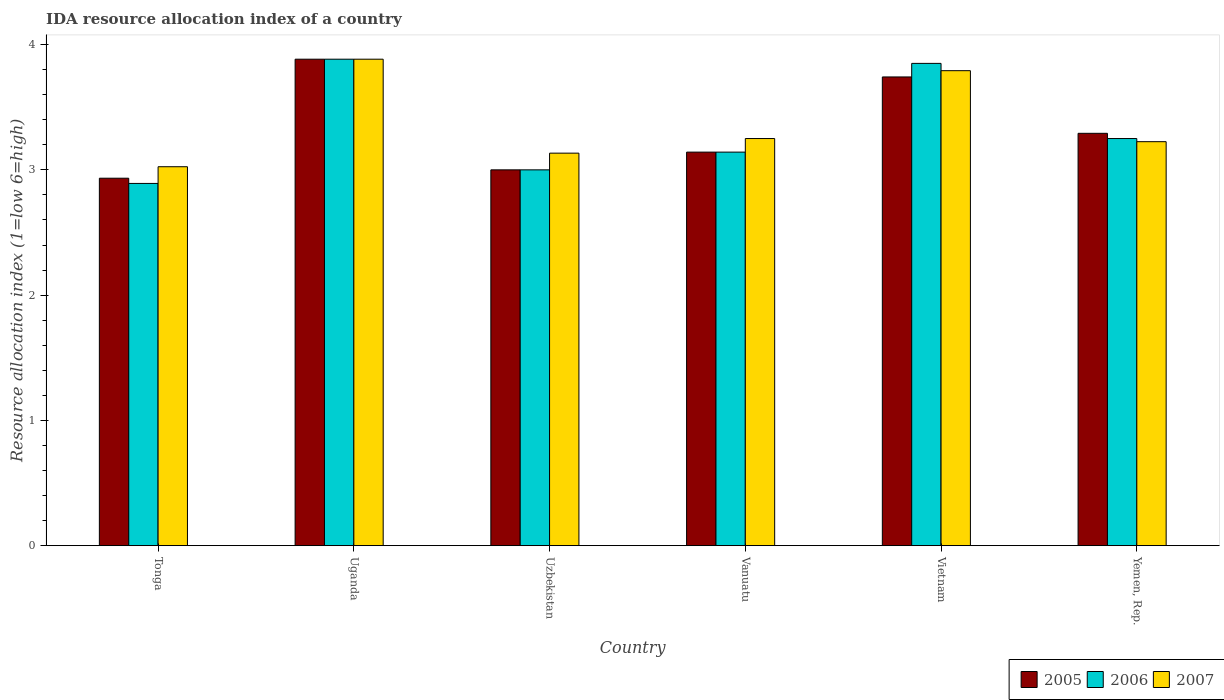How many groups of bars are there?
Offer a terse response. 6. Are the number of bars per tick equal to the number of legend labels?
Your response must be concise. Yes. How many bars are there on the 6th tick from the left?
Offer a very short reply. 3. How many bars are there on the 6th tick from the right?
Give a very brief answer. 3. What is the label of the 3rd group of bars from the left?
Ensure brevity in your answer.  Uzbekistan. What is the IDA resource allocation index in 2006 in Uzbekistan?
Make the answer very short. 3. Across all countries, what is the maximum IDA resource allocation index in 2005?
Your answer should be very brief. 3.88. Across all countries, what is the minimum IDA resource allocation index in 2006?
Offer a very short reply. 2.89. In which country was the IDA resource allocation index in 2007 maximum?
Offer a terse response. Uganda. In which country was the IDA resource allocation index in 2005 minimum?
Your answer should be compact. Tonga. What is the total IDA resource allocation index in 2005 in the graph?
Your answer should be very brief. 19.99. What is the difference between the IDA resource allocation index in 2006 in Tonga and that in Uzbekistan?
Offer a very short reply. -0.11. What is the difference between the IDA resource allocation index in 2005 in Vietnam and the IDA resource allocation index in 2007 in Tonga?
Keep it short and to the point. 0.72. What is the average IDA resource allocation index in 2005 per country?
Your answer should be very brief. 3.33. What is the difference between the IDA resource allocation index of/in 2005 and IDA resource allocation index of/in 2006 in Vietnam?
Offer a very short reply. -0.11. What is the ratio of the IDA resource allocation index in 2006 in Tonga to that in Vietnam?
Your response must be concise. 0.75. Is the difference between the IDA resource allocation index in 2005 in Tonga and Vietnam greater than the difference between the IDA resource allocation index in 2006 in Tonga and Vietnam?
Your answer should be compact. Yes. What is the difference between the highest and the second highest IDA resource allocation index in 2006?
Make the answer very short. 0.6. What is the difference between the highest and the lowest IDA resource allocation index in 2007?
Your answer should be compact. 0.86. Is the sum of the IDA resource allocation index in 2005 in Uganda and Uzbekistan greater than the maximum IDA resource allocation index in 2007 across all countries?
Offer a very short reply. Yes. Is it the case that in every country, the sum of the IDA resource allocation index in 2007 and IDA resource allocation index in 2005 is greater than the IDA resource allocation index in 2006?
Give a very brief answer. Yes. How many bars are there?
Offer a terse response. 18. Are all the bars in the graph horizontal?
Provide a short and direct response. No. How many countries are there in the graph?
Keep it short and to the point. 6. Does the graph contain grids?
Give a very brief answer. No. Where does the legend appear in the graph?
Your answer should be very brief. Bottom right. How many legend labels are there?
Keep it short and to the point. 3. How are the legend labels stacked?
Ensure brevity in your answer.  Horizontal. What is the title of the graph?
Make the answer very short. IDA resource allocation index of a country. Does "1964" appear as one of the legend labels in the graph?
Offer a very short reply. No. What is the label or title of the Y-axis?
Your answer should be compact. Resource allocation index (1=low 6=high). What is the Resource allocation index (1=low 6=high) in 2005 in Tonga?
Keep it short and to the point. 2.93. What is the Resource allocation index (1=low 6=high) of 2006 in Tonga?
Your response must be concise. 2.89. What is the Resource allocation index (1=low 6=high) of 2007 in Tonga?
Provide a succinct answer. 3.02. What is the Resource allocation index (1=low 6=high) of 2005 in Uganda?
Your answer should be very brief. 3.88. What is the Resource allocation index (1=low 6=high) of 2006 in Uganda?
Make the answer very short. 3.88. What is the Resource allocation index (1=low 6=high) in 2007 in Uganda?
Give a very brief answer. 3.88. What is the Resource allocation index (1=low 6=high) of 2005 in Uzbekistan?
Your response must be concise. 3. What is the Resource allocation index (1=low 6=high) of 2007 in Uzbekistan?
Offer a terse response. 3.13. What is the Resource allocation index (1=low 6=high) in 2005 in Vanuatu?
Your answer should be compact. 3.14. What is the Resource allocation index (1=low 6=high) in 2006 in Vanuatu?
Make the answer very short. 3.14. What is the Resource allocation index (1=low 6=high) in 2005 in Vietnam?
Provide a short and direct response. 3.74. What is the Resource allocation index (1=low 6=high) in 2006 in Vietnam?
Your answer should be very brief. 3.85. What is the Resource allocation index (1=low 6=high) of 2007 in Vietnam?
Offer a terse response. 3.79. What is the Resource allocation index (1=low 6=high) in 2005 in Yemen, Rep.?
Your response must be concise. 3.29. What is the Resource allocation index (1=low 6=high) of 2007 in Yemen, Rep.?
Provide a succinct answer. 3.23. Across all countries, what is the maximum Resource allocation index (1=low 6=high) of 2005?
Give a very brief answer. 3.88. Across all countries, what is the maximum Resource allocation index (1=low 6=high) of 2006?
Offer a terse response. 3.88. Across all countries, what is the maximum Resource allocation index (1=low 6=high) of 2007?
Your response must be concise. 3.88. Across all countries, what is the minimum Resource allocation index (1=low 6=high) of 2005?
Your answer should be compact. 2.93. Across all countries, what is the minimum Resource allocation index (1=low 6=high) in 2006?
Provide a short and direct response. 2.89. Across all countries, what is the minimum Resource allocation index (1=low 6=high) in 2007?
Your answer should be very brief. 3.02. What is the total Resource allocation index (1=low 6=high) of 2005 in the graph?
Provide a succinct answer. 19.99. What is the total Resource allocation index (1=low 6=high) of 2006 in the graph?
Give a very brief answer. 20.02. What is the total Resource allocation index (1=low 6=high) of 2007 in the graph?
Your response must be concise. 20.31. What is the difference between the Resource allocation index (1=low 6=high) in 2005 in Tonga and that in Uganda?
Offer a very short reply. -0.95. What is the difference between the Resource allocation index (1=low 6=high) in 2006 in Tonga and that in Uganda?
Provide a succinct answer. -0.99. What is the difference between the Resource allocation index (1=low 6=high) of 2007 in Tonga and that in Uganda?
Provide a succinct answer. -0.86. What is the difference between the Resource allocation index (1=low 6=high) in 2005 in Tonga and that in Uzbekistan?
Ensure brevity in your answer.  -0.07. What is the difference between the Resource allocation index (1=low 6=high) in 2006 in Tonga and that in Uzbekistan?
Your answer should be compact. -0.11. What is the difference between the Resource allocation index (1=low 6=high) of 2007 in Tonga and that in Uzbekistan?
Offer a very short reply. -0.11. What is the difference between the Resource allocation index (1=low 6=high) of 2005 in Tonga and that in Vanuatu?
Offer a very short reply. -0.21. What is the difference between the Resource allocation index (1=low 6=high) of 2006 in Tonga and that in Vanuatu?
Keep it short and to the point. -0.25. What is the difference between the Resource allocation index (1=low 6=high) of 2007 in Tonga and that in Vanuatu?
Give a very brief answer. -0.23. What is the difference between the Resource allocation index (1=low 6=high) of 2005 in Tonga and that in Vietnam?
Give a very brief answer. -0.81. What is the difference between the Resource allocation index (1=low 6=high) in 2006 in Tonga and that in Vietnam?
Your answer should be compact. -0.96. What is the difference between the Resource allocation index (1=low 6=high) of 2007 in Tonga and that in Vietnam?
Keep it short and to the point. -0.77. What is the difference between the Resource allocation index (1=low 6=high) of 2005 in Tonga and that in Yemen, Rep.?
Your answer should be compact. -0.36. What is the difference between the Resource allocation index (1=low 6=high) of 2006 in Tonga and that in Yemen, Rep.?
Offer a very short reply. -0.36. What is the difference between the Resource allocation index (1=low 6=high) of 2005 in Uganda and that in Uzbekistan?
Give a very brief answer. 0.88. What is the difference between the Resource allocation index (1=low 6=high) of 2006 in Uganda and that in Uzbekistan?
Your response must be concise. 0.88. What is the difference between the Resource allocation index (1=low 6=high) of 2005 in Uganda and that in Vanuatu?
Your response must be concise. 0.74. What is the difference between the Resource allocation index (1=low 6=high) in 2006 in Uganda and that in Vanuatu?
Offer a very short reply. 0.74. What is the difference between the Resource allocation index (1=low 6=high) in 2007 in Uganda and that in Vanuatu?
Keep it short and to the point. 0.63. What is the difference between the Resource allocation index (1=low 6=high) of 2005 in Uganda and that in Vietnam?
Your response must be concise. 0.14. What is the difference between the Resource allocation index (1=low 6=high) of 2006 in Uganda and that in Vietnam?
Your answer should be compact. 0.03. What is the difference between the Resource allocation index (1=low 6=high) of 2007 in Uganda and that in Vietnam?
Your answer should be very brief. 0.09. What is the difference between the Resource allocation index (1=low 6=high) of 2005 in Uganda and that in Yemen, Rep.?
Offer a terse response. 0.59. What is the difference between the Resource allocation index (1=low 6=high) of 2006 in Uganda and that in Yemen, Rep.?
Keep it short and to the point. 0.63. What is the difference between the Resource allocation index (1=low 6=high) in 2007 in Uganda and that in Yemen, Rep.?
Your answer should be compact. 0.66. What is the difference between the Resource allocation index (1=low 6=high) in 2005 in Uzbekistan and that in Vanuatu?
Provide a short and direct response. -0.14. What is the difference between the Resource allocation index (1=low 6=high) of 2006 in Uzbekistan and that in Vanuatu?
Ensure brevity in your answer.  -0.14. What is the difference between the Resource allocation index (1=low 6=high) of 2007 in Uzbekistan and that in Vanuatu?
Your answer should be very brief. -0.12. What is the difference between the Resource allocation index (1=low 6=high) of 2005 in Uzbekistan and that in Vietnam?
Provide a succinct answer. -0.74. What is the difference between the Resource allocation index (1=low 6=high) in 2006 in Uzbekistan and that in Vietnam?
Provide a short and direct response. -0.85. What is the difference between the Resource allocation index (1=low 6=high) in 2007 in Uzbekistan and that in Vietnam?
Your answer should be very brief. -0.66. What is the difference between the Resource allocation index (1=low 6=high) of 2005 in Uzbekistan and that in Yemen, Rep.?
Offer a very short reply. -0.29. What is the difference between the Resource allocation index (1=low 6=high) of 2006 in Uzbekistan and that in Yemen, Rep.?
Provide a short and direct response. -0.25. What is the difference between the Resource allocation index (1=low 6=high) of 2007 in Uzbekistan and that in Yemen, Rep.?
Ensure brevity in your answer.  -0.09. What is the difference between the Resource allocation index (1=low 6=high) in 2006 in Vanuatu and that in Vietnam?
Your answer should be compact. -0.71. What is the difference between the Resource allocation index (1=low 6=high) in 2007 in Vanuatu and that in Vietnam?
Keep it short and to the point. -0.54. What is the difference between the Resource allocation index (1=low 6=high) in 2005 in Vanuatu and that in Yemen, Rep.?
Keep it short and to the point. -0.15. What is the difference between the Resource allocation index (1=low 6=high) of 2006 in Vanuatu and that in Yemen, Rep.?
Make the answer very short. -0.11. What is the difference between the Resource allocation index (1=low 6=high) in 2007 in Vanuatu and that in Yemen, Rep.?
Provide a succinct answer. 0.03. What is the difference between the Resource allocation index (1=low 6=high) in 2005 in Vietnam and that in Yemen, Rep.?
Keep it short and to the point. 0.45. What is the difference between the Resource allocation index (1=low 6=high) of 2007 in Vietnam and that in Yemen, Rep.?
Ensure brevity in your answer.  0.57. What is the difference between the Resource allocation index (1=low 6=high) in 2005 in Tonga and the Resource allocation index (1=low 6=high) in 2006 in Uganda?
Your answer should be compact. -0.95. What is the difference between the Resource allocation index (1=low 6=high) in 2005 in Tonga and the Resource allocation index (1=low 6=high) in 2007 in Uganda?
Provide a succinct answer. -0.95. What is the difference between the Resource allocation index (1=low 6=high) of 2006 in Tonga and the Resource allocation index (1=low 6=high) of 2007 in Uganda?
Make the answer very short. -0.99. What is the difference between the Resource allocation index (1=low 6=high) of 2005 in Tonga and the Resource allocation index (1=low 6=high) of 2006 in Uzbekistan?
Your answer should be very brief. -0.07. What is the difference between the Resource allocation index (1=low 6=high) of 2005 in Tonga and the Resource allocation index (1=low 6=high) of 2007 in Uzbekistan?
Give a very brief answer. -0.2. What is the difference between the Resource allocation index (1=low 6=high) of 2006 in Tonga and the Resource allocation index (1=low 6=high) of 2007 in Uzbekistan?
Offer a very short reply. -0.24. What is the difference between the Resource allocation index (1=low 6=high) in 2005 in Tonga and the Resource allocation index (1=low 6=high) in 2006 in Vanuatu?
Keep it short and to the point. -0.21. What is the difference between the Resource allocation index (1=low 6=high) of 2005 in Tonga and the Resource allocation index (1=low 6=high) of 2007 in Vanuatu?
Your answer should be very brief. -0.32. What is the difference between the Resource allocation index (1=low 6=high) of 2006 in Tonga and the Resource allocation index (1=low 6=high) of 2007 in Vanuatu?
Offer a terse response. -0.36. What is the difference between the Resource allocation index (1=low 6=high) of 2005 in Tonga and the Resource allocation index (1=low 6=high) of 2006 in Vietnam?
Offer a very short reply. -0.92. What is the difference between the Resource allocation index (1=low 6=high) in 2005 in Tonga and the Resource allocation index (1=low 6=high) in 2007 in Vietnam?
Offer a very short reply. -0.86. What is the difference between the Resource allocation index (1=low 6=high) in 2006 in Tonga and the Resource allocation index (1=low 6=high) in 2007 in Vietnam?
Provide a short and direct response. -0.9. What is the difference between the Resource allocation index (1=low 6=high) in 2005 in Tonga and the Resource allocation index (1=low 6=high) in 2006 in Yemen, Rep.?
Make the answer very short. -0.32. What is the difference between the Resource allocation index (1=low 6=high) of 2005 in Tonga and the Resource allocation index (1=low 6=high) of 2007 in Yemen, Rep.?
Ensure brevity in your answer.  -0.29. What is the difference between the Resource allocation index (1=low 6=high) in 2006 in Tonga and the Resource allocation index (1=low 6=high) in 2007 in Yemen, Rep.?
Your answer should be very brief. -0.33. What is the difference between the Resource allocation index (1=low 6=high) in 2005 in Uganda and the Resource allocation index (1=low 6=high) in 2006 in Uzbekistan?
Your answer should be compact. 0.88. What is the difference between the Resource allocation index (1=low 6=high) of 2005 in Uganda and the Resource allocation index (1=low 6=high) of 2006 in Vanuatu?
Ensure brevity in your answer.  0.74. What is the difference between the Resource allocation index (1=low 6=high) in 2005 in Uganda and the Resource allocation index (1=low 6=high) in 2007 in Vanuatu?
Your answer should be very brief. 0.63. What is the difference between the Resource allocation index (1=low 6=high) of 2006 in Uganda and the Resource allocation index (1=low 6=high) of 2007 in Vanuatu?
Offer a terse response. 0.63. What is the difference between the Resource allocation index (1=low 6=high) of 2005 in Uganda and the Resource allocation index (1=low 6=high) of 2007 in Vietnam?
Offer a very short reply. 0.09. What is the difference between the Resource allocation index (1=low 6=high) in 2006 in Uganda and the Resource allocation index (1=low 6=high) in 2007 in Vietnam?
Provide a short and direct response. 0.09. What is the difference between the Resource allocation index (1=low 6=high) of 2005 in Uganda and the Resource allocation index (1=low 6=high) of 2006 in Yemen, Rep.?
Provide a short and direct response. 0.63. What is the difference between the Resource allocation index (1=low 6=high) in 2005 in Uganda and the Resource allocation index (1=low 6=high) in 2007 in Yemen, Rep.?
Offer a terse response. 0.66. What is the difference between the Resource allocation index (1=low 6=high) of 2006 in Uganda and the Resource allocation index (1=low 6=high) of 2007 in Yemen, Rep.?
Make the answer very short. 0.66. What is the difference between the Resource allocation index (1=low 6=high) in 2005 in Uzbekistan and the Resource allocation index (1=low 6=high) in 2006 in Vanuatu?
Offer a terse response. -0.14. What is the difference between the Resource allocation index (1=low 6=high) of 2005 in Uzbekistan and the Resource allocation index (1=low 6=high) of 2006 in Vietnam?
Your response must be concise. -0.85. What is the difference between the Resource allocation index (1=low 6=high) of 2005 in Uzbekistan and the Resource allocation index (1=low 6=high) of 2007 in Vietnam?
Offer a terse response. -0.79. What is the difference between the Resource allocation index (1=low 6=high) of 2006 in Uzbekistan and the Resource allocation index (1=low 6=high) of 2007 in Vietnam?
Your answer should be very brief. -0.79. What is the difference between the Resource allocation index (1=low 6=high) in 2005 in Uzbekistan and the Resource allocation index (1=low 6=high) in 2006 in Yemen, Rep.?
Provide a succinct answer. -0.25. What is the difference between the Resource allocation index (1=low 6=high) in 2005 in Uzbekistan and the Resource allocation index (1=low 6=high) in 2007 in Yemen, Rep.?
Offer a very short reply. -0.23. What is the difference between the Resource allocation index (1=low 6=high) in 2006 in Uzbekistan and the Resource allocation index (1=low 6=high) in 2007 in Yemen, Rep.?
Ensure brevity in your answer.  -0.23. What is the difference between the Resource allocation index (1=low 6=high) of 2005 in Vanuatu and the Resource allocation index (1=low 6=high) of 2006 in Vietnam?
Make the answer very short. -0.71. What is the difference between the Resource allocation index (1=low 6=high) in 2005 in Vanuatu and the Resource allocation index (1=low 6=high) in 2007 in Vietnam?
Offer a very short reply. -0.65. What is the difference between the Resource allocation index (1=low 6=high) in 2006 in Vanuatu and the Resource allocation index (1=low 6=high) in 2007 in Vietnam?
Your answer should be compact. -0.65. What is the difference between the Resource allocation index (1=low 6=high) of 2005 in Vanuatu and the Resource allocation index (1=low 6=high) of 2006 in Yemen, Rep.?
Make the answer very short. -0.11. What is the difference between the Resource allocation index (1=low 6=high) in 2005 in Vanuatu and the Resource allocation index (1=low 6=high) in 2007 in Yemen, Rep.?
Provide a short and direct response. -0.08. What is the difference between the Resource allocation index (1=low 6=high) in 2006 in Vanuatu and the Resource allocation index (1=low 6=high) in 2007 in Yemen, Rep.?
Give a very brief answer. -0.08. What is the difference between the Resource allocation index (1=low 6=high) in 2005 in Vietnam and the Resource allocation index (1=low 6=high) in 2006 in Yemen, Rep.?
Keep it short and to the point. 0.49. What is the difference between the Resource allocation index (1=low 6=high) in 2005 in Vietnam and the Resource allocation index (1=low 6=high) in 2007 in Yemen, Rep.?
Keep it short and to the point. 0.52. What is the average Resource allocation index (1=low 6=high) of 2005 per country?
Provide a succinct answer. 3.33. What is the average Resource allocation index (1=low 6=high) of 2006 per country?
Offer a terse response. 3.34. What is the average Resource allocation index (1=low 6=high) of 2007 per country?
Make the answer very short. 3.38. What is the difference between the Resource allocation index (1=low 6=high) of 2005 and Resource allocation index (1=low 6=high) of 2006 in Tonga?
Offer a very short reply. 0.04. What is the difference between the Resource allocation index (1=low 6=high) of 2005 and Resource allocation index (1=low 6=high) of 2007 in Tonga?
Offer a very short reply. -0.09. What is the difference between the Resource allocation index (1=low 6=high) of 2006 and Resource allocation index (1=low 6=high) of 2007 in Tonga?
Your response must be concise. -0.13. What is the difference between the Resource allocation index (1=low 6=high) in 2005 and Resource allocation index (1=low 6=high) in 2006 in Uganda?
Make the answer very short. 0. What is the difference between the Resource allocation index (1=low 6=high) in 2005 and Resource allocation index (1=low 6=high) in 2007 in Uganda?
Offer a terse response. 0. What is the difference between the Resource allocation index (1=low 6=high) of 2006 and Resource allocation index (1=low 6=high) of 2007 in Uganda?
Ensure brevity in your answer.  0. What is the difference between the Resource allocation index (1=low 6=high) in 2005 and Resource allocation index (1=low 6=high) in 2006 in Uzbekistan?
Provide a succinct answer. 0. What is the difference between the Resource allocation index (1=low 6=high) of 2005 and Resource allocation index (1=low 6=high) of 2007 in Uzbekistan?
Your answer should be very brief. -0.13. What is the difference between the Resource allocation index (1=low 6=high) in 2006 and Resource allocation index (1=low 6=high) in 2007 in Uzbekistan?
Ensure brevity in your answer.  -0.13. What is the difference between the Resource allocation index (1=low 6=high) in 2005 and Resource allocation index (1=low 6=high) in 2006 in Vanuatu?
Give a very brief answer. 0. What is the difference between the Resource allocation index (1=low 6=high) of 2005 and Resource allocation index (1=low 6=high) of 2007 in Vanuatu?
Keep it short and to the point. -0.11. What is the difference between the Resource allocation index (1=low 6=high) in 2006 and Resource allocation index (1=low 6=high) in 2007 in Vanuatu?
Offer a terse response. -0.11. What is the difference between the Resource allocation index (1=low 6=high) of 2005 and Resource allocation index (1=low 6=high) of 2006 in Vietnam?
Your response must be concise. -0.11. What is the difference between the Resource allocation index (1=low 6=high) in 2006 and Resource allocation index (1=low 6=high) in 2007 in Vietnam?
Provide a succinct answer. 0.06. What is the difference between the Resource allocation index (1=low 6=high) in 2005 and Resource allocation index (1=low 6=high) in 2006 in Yemen, Rep.?
Make the answer very short. 0.04. What is the difference between the Resource allocation index (1=low 6=high) of 2005 and Resource allocation index (1=low 6=high) of 2007 in Yemen, Rep.?
Offer a terse response. 0.07. What is the difference between the Resource allocation index (1=low 6=high) in 2006 and Resource allocation index (1=low 6=high) in 2007 in Yemen, Rep.?
Make the answer very short. 0.03. What is the ratio of the Resource allocation index (1=low 6=high) of 2005 in Tonga to that in Uganda?
Offer a very short reply. 0.76. What is the ratio of the Resource allocation index (1=low 6=high) of 2006 in Tonga to that in Uganda?
Provide a short and direct response. 0.74. What is the ratio of the Resource allocation index (1=low 6=high) of 2007 in Tonga to that in Uganda?
Your answer should be very brief. 0.78. What is the ratio of the Resource allocation index (1=low 6=high) in 2005 in Tonga to that in Uzbekistan?
Ensure brevity in your answer.  0.98. What is the ratio of the Resource allocation index (1=low 6=high) of 2006 in Tonga to that in Uzbekistan?
Provide a short and direct response. 0.96. What is the ratio of the Resource allocation index (1=low 6=high) of 2007 in Tonga to that in Uzbekistan?
Provide a short and direct response. 0.97. What is the ratio of the Resource allocation index (1=low 6=high) of 2005 in Tonga to that in Vanuatu?
Provide a succinct answer. 0.93. What is the ratio of the Resource allocation index (1=low 6=high) in 2006 in Tonga to that in Vanuatu?
Offer a terse response. 0.92. What is the ratio of the Resource allocation index (1=low 6=high) of 2007 in Tonga to that in Vanuatu?
Provide a succinct answer. 0.93. What is the ratio of the Resource allocation index (1=low 6=high) of 2005 in Tonga to that in Vietnam?
Provide a succinct answer. 0.78. What is the ratio of the Resource allocation index (1=low 6=high) in 2006 in Tonga to that in Vietnam?
Your response must be concise. 0.75. What is the ratio of the Resource allocation index (1=low 6=high) in 2007 in Tonga to that in Vietnam?
Give a very brief answer. 0.8. What is the ratio of the Resource allocation index (1=low 6=high) of 2005 in Tonga to that in Yemen, Rep.?
Keep it short and to the point. 0.89. What is the ratio of the Resource allocation index (1=low 6=high) in 2006 in Tonga to that in Yemen, Rep.?
Your response must be concise. 0.89. What is the ratio of the Resource allocation index (1=low 6=high) in 2007 in Tonga to that in Yemen, Rep.?
Your answer should be very brief. 0.94. What is the ratio of the Resource allocation index (1=low 6=high) in 2005 in Uganda to that in Uzbekistan?
Ensure brevity in your answer.  1.29. What is the ratio of the Resource allocation index (1=low 6=high) of 2006 in Uganda to that in Uzbekistan?
Offer a very short reply. 1.29. What is the ratio of the Resource allocation index (1=low 6=high) in 2007 in Uganda to that in Uzbekistan?
Your answer should be very brief. 1.24. What is the ratio of the Resource allocation index (1=low 6=high) in 2005 in Uganda to that in Vanuatu?
Your answer should be compact. 1.24. What is the ratio of the Resource allocation index (1=low 6=high) in 2006 in Uganda to that in Vanuatu?
Your response must be concise. 1.24. What is the ratio of the Resource allocation index (1=low 6=high) of 2007 in Uganda to that in Vanuatu?
Your answer should be compact. 1.19. What is the ratio of the Resource allocation index (1=low 6=high) in 2005 in Uganda to that in Vietnam?
Provide a succinct answer. 1.04. What is the ratio of the Resource allocation index (1=low 6=high) of 2006 in Uganda to that in Vietnam?
Provide a short and direct response. 1.01. What is the ratio of the Resource allocation index (1=low 6=high) in 2007 in Uganda to that in Vietnam?
Your response must be concise. 1.02. What is the ratio of the Resource allocation index (1=low 6=high) in 2005 in Uganda to that in Yemen, Rep.?
Your response must be concise. 1.18. What is the ratio of the Resource allocation index (1=low 6=high) of 2006 in Uganda to that in Yemen, Rep.?
Ensure brevity in your answer.  1.19. What is the ratio of the Resource allocation index (1=low 6=high) of 2007 in Uganda to that in Yemen, Rep.?
Offer a terse response. 1.2. What is the ratio of the Resource allocation index (1=low 6=high) in 2005 in Uzbekistan to that in Vanuatu?
Offer a very short reply. 0.95. What is the ratio of the Resource allocation index (1=low 6=high) in 2006 in Uzbekistan to that in Vanuatu?
Your answer should be compact. 0.95. What is the ratio of the Resource allocation index (1=low 6=high) in 2007 in Uzbekistan to that in Vanuatu?
Give a very brief answer. 0.96. What is the ratio of the Resource allocation index (1=low 6=high) in 2005 in Uzbekistan to that in Vietnam?
Your answer should be compact. 0.8. What is the ratio of the Resource allocation index (1=low 6=high) of 2006 in Uzbekistan to that in Vietnam?
Ensure brevity in your answer.  0.78. What is the ratio of the Resource allocation index (1=low 6=high) of 2007 in Uzbekistan to that in Vietnam?
Your answer should be compact. 0.83. What is the ratio of the Resource allocation index (1=low 6=high) in 2005 in Uzbekistan to that in Yemen, Rep.?
Provide a short and direct response. 0.91. What is the ratio of the Resource allocation index (1=low 6=high) of 2007 in Uzbekistan to that in Yemen, Rep.?
Ensure brevity in your answer.  0.97. What is the ratio of the Resource allocation index (1=low 6=high) of 2005 in Vanuatu to that in Vietnam?
Provide a short and direct response. 0.84. What is the ratio of the Resource allocation index (1=low 6=high) of 2006 in Vanuatu to that in Vietnam?
Offer a terse response. 0.82. What is the ratio of the Resource allocation index (1=low 6=high) of 2007 in Vanuatu to that in Vietnam?
Your response must be concise. 0.86. What is the ratio of the Resource allocation index (1=low 6=high) of 2005 in Vanuatu to that in Yemen, Rep.?
Make the answer very short. 0.95. What is the ratio of the Resource allocation index (1=low 6=high) in 2006 in Vanuatu to that in Yemen, Rep.?
Keep it short and to the point. 0.97. What is the ratio of the Resource allocation index (1=low 6=high) in 2007 in Vanuatu to that in Yemen, Rep.?
Your answer should be very brief. 1.01. What is the ratio of the Resource allocation index (1=low 6=high) of 2005 in Vietnam to that in Yemen, Rep.?
Make the answer very short. 1.14. What is the ratio of the Resource allocation index (1=low 6=high) of 2006 in Vietnam to that in Yemen, Rep.?
Keep it short and to the point. 1.18. What is the ratio of the Resource allocation index (1=low 6=high) in 2007 in Vietnam to that in Yemen, Rep.?
Give a very brief answer. 1.18. What is the difference between the highest and the second highest Resource allocation index (1=low 6=high) in 2005?
Give a very brief answer. 0.14. What is the difference between the highest and the second highest Resource allocation index (1=low 6=high) of 2007?
Offer a very short reply. 0.09. What is the difference between the highest and the lowest Resource allocation index (1=low 6=high) in 2005?
Your answer should be very brief. 0.95. What is the difference between the highest and the lowest Resource allocation index (1=low 6=high) in 2006?
Provide a succinct answer. 0.99. What is the difference between the highest and the lowest Resource allocation index (1=low 6=high) of 2007?
Offer a terse response. 0.86. 